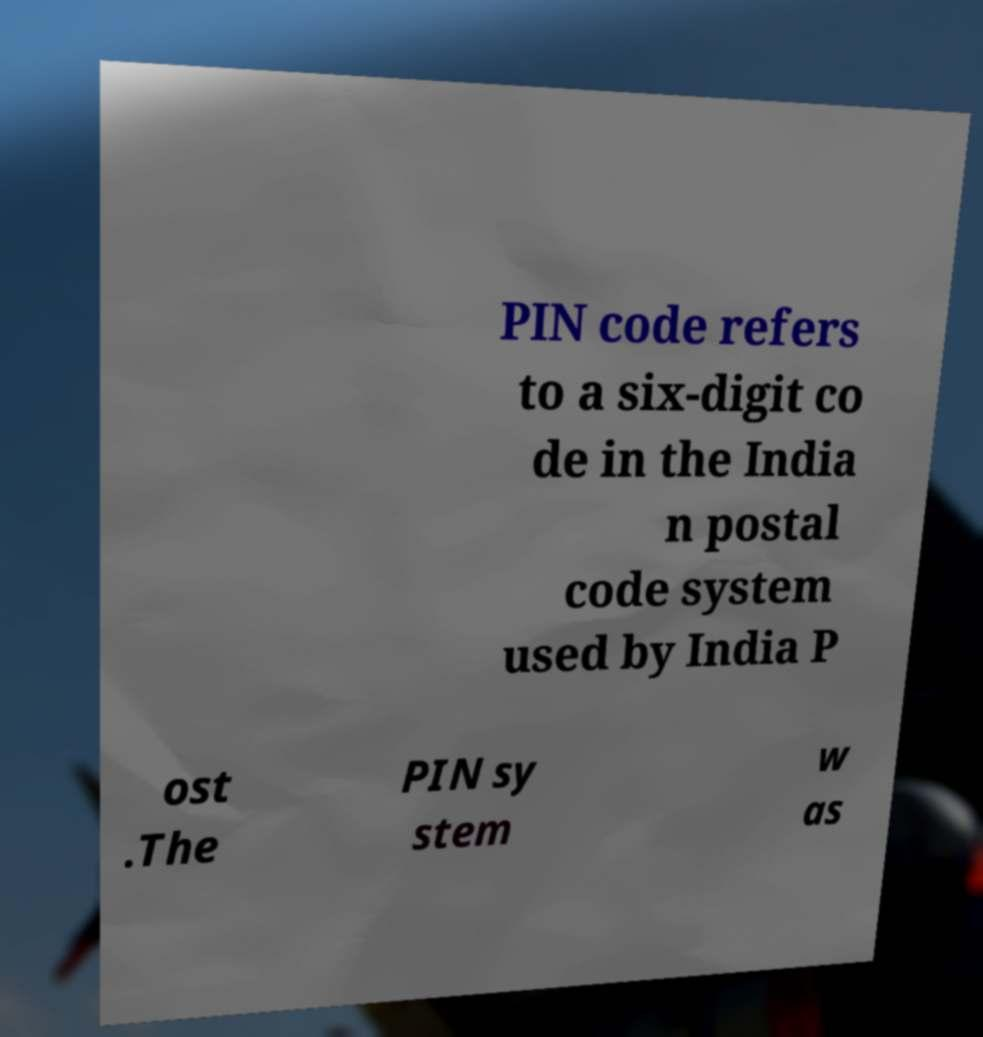Could you extract and type out the text from this image? PIN code refers to a six-digit co de in the India n postal code system used by India P ost .The PIN sy stem w as 